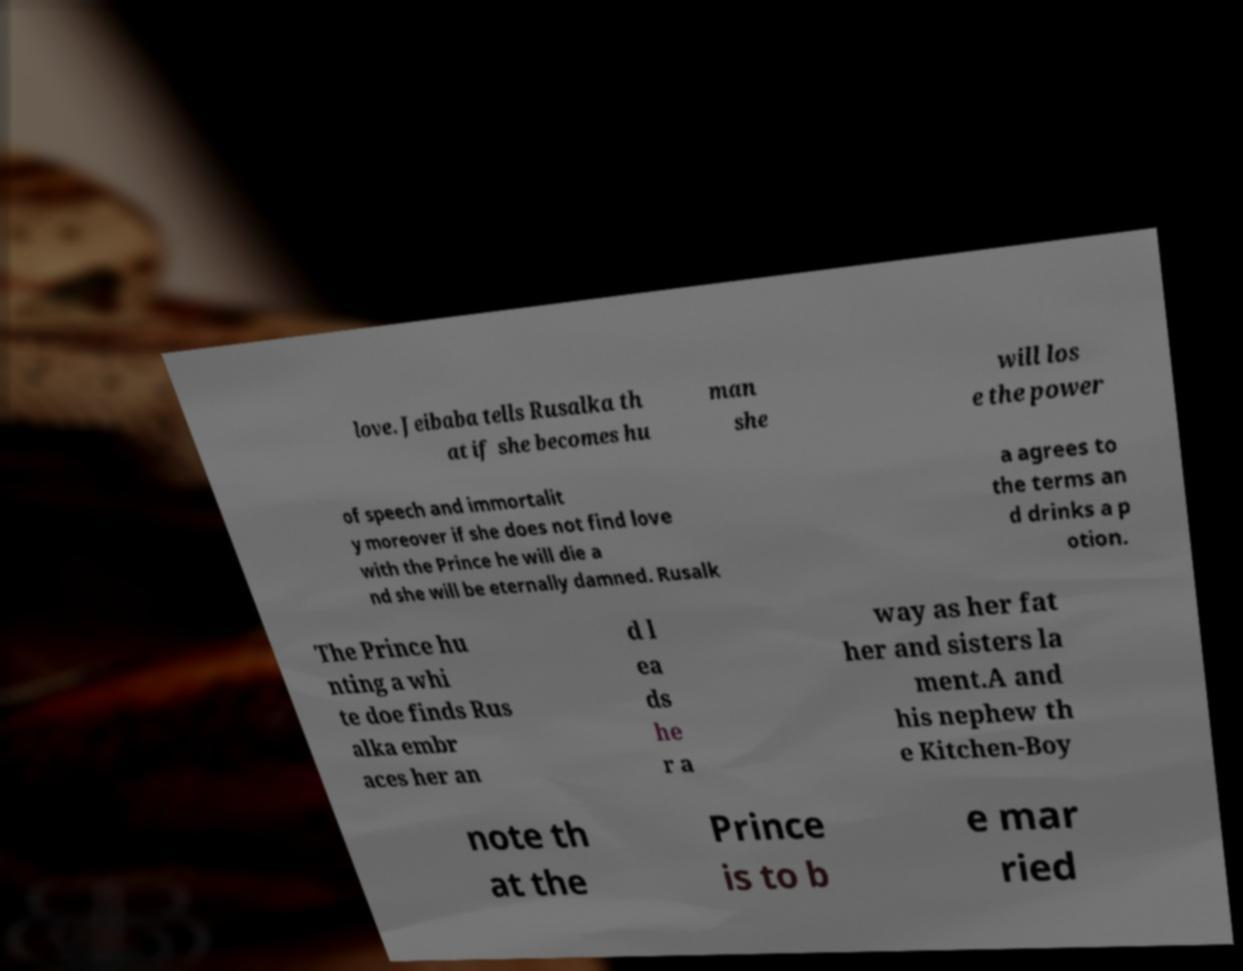For documentation purposes, I need the text within this image transcribed. Could you provide that? love. Jeibaba tells Rusalka th at if she becomes hu man she will los e the power of speech and immortalit y moreover if she does not find love with the Prince he will die a nd she will be eternally damned. Rusalk a agrees to the terms an d drinks a p otion. The Prince hu nting a whi te doe finds Rus alka embr aces her an d l ea ds he r a way as her fat her and sisters la ment.A and his nephew th e Kitchen-Boy note th at the Prince is to b e mar ried 